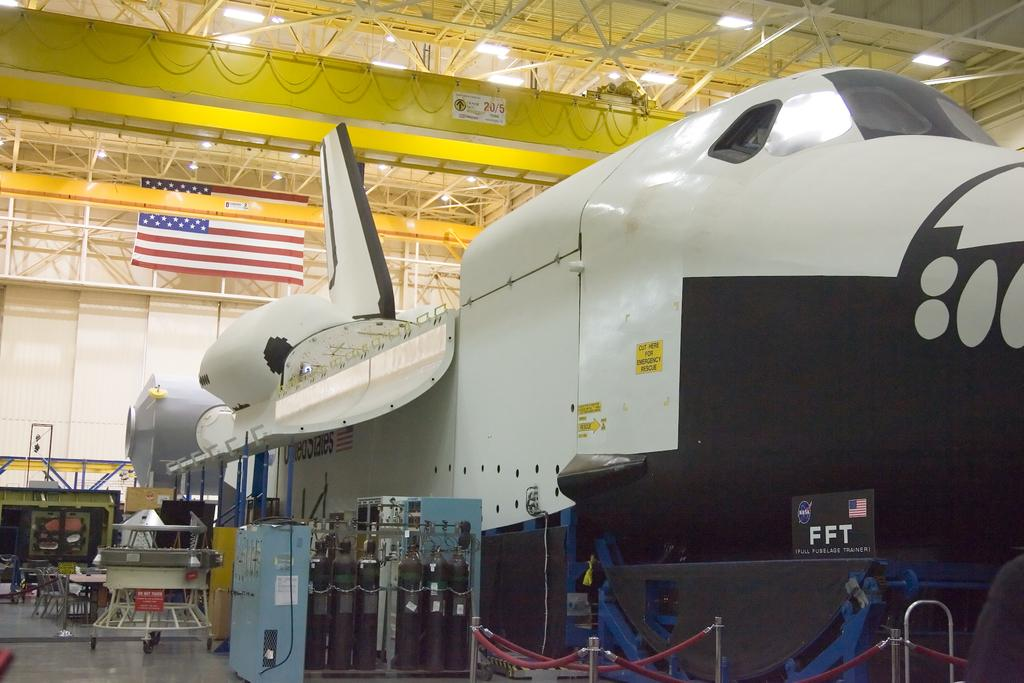Provide a one-sentence caption for the provided image. A space shuttle is in its hanger and has FFT, Full Fuselage Trainer. on its front end. 